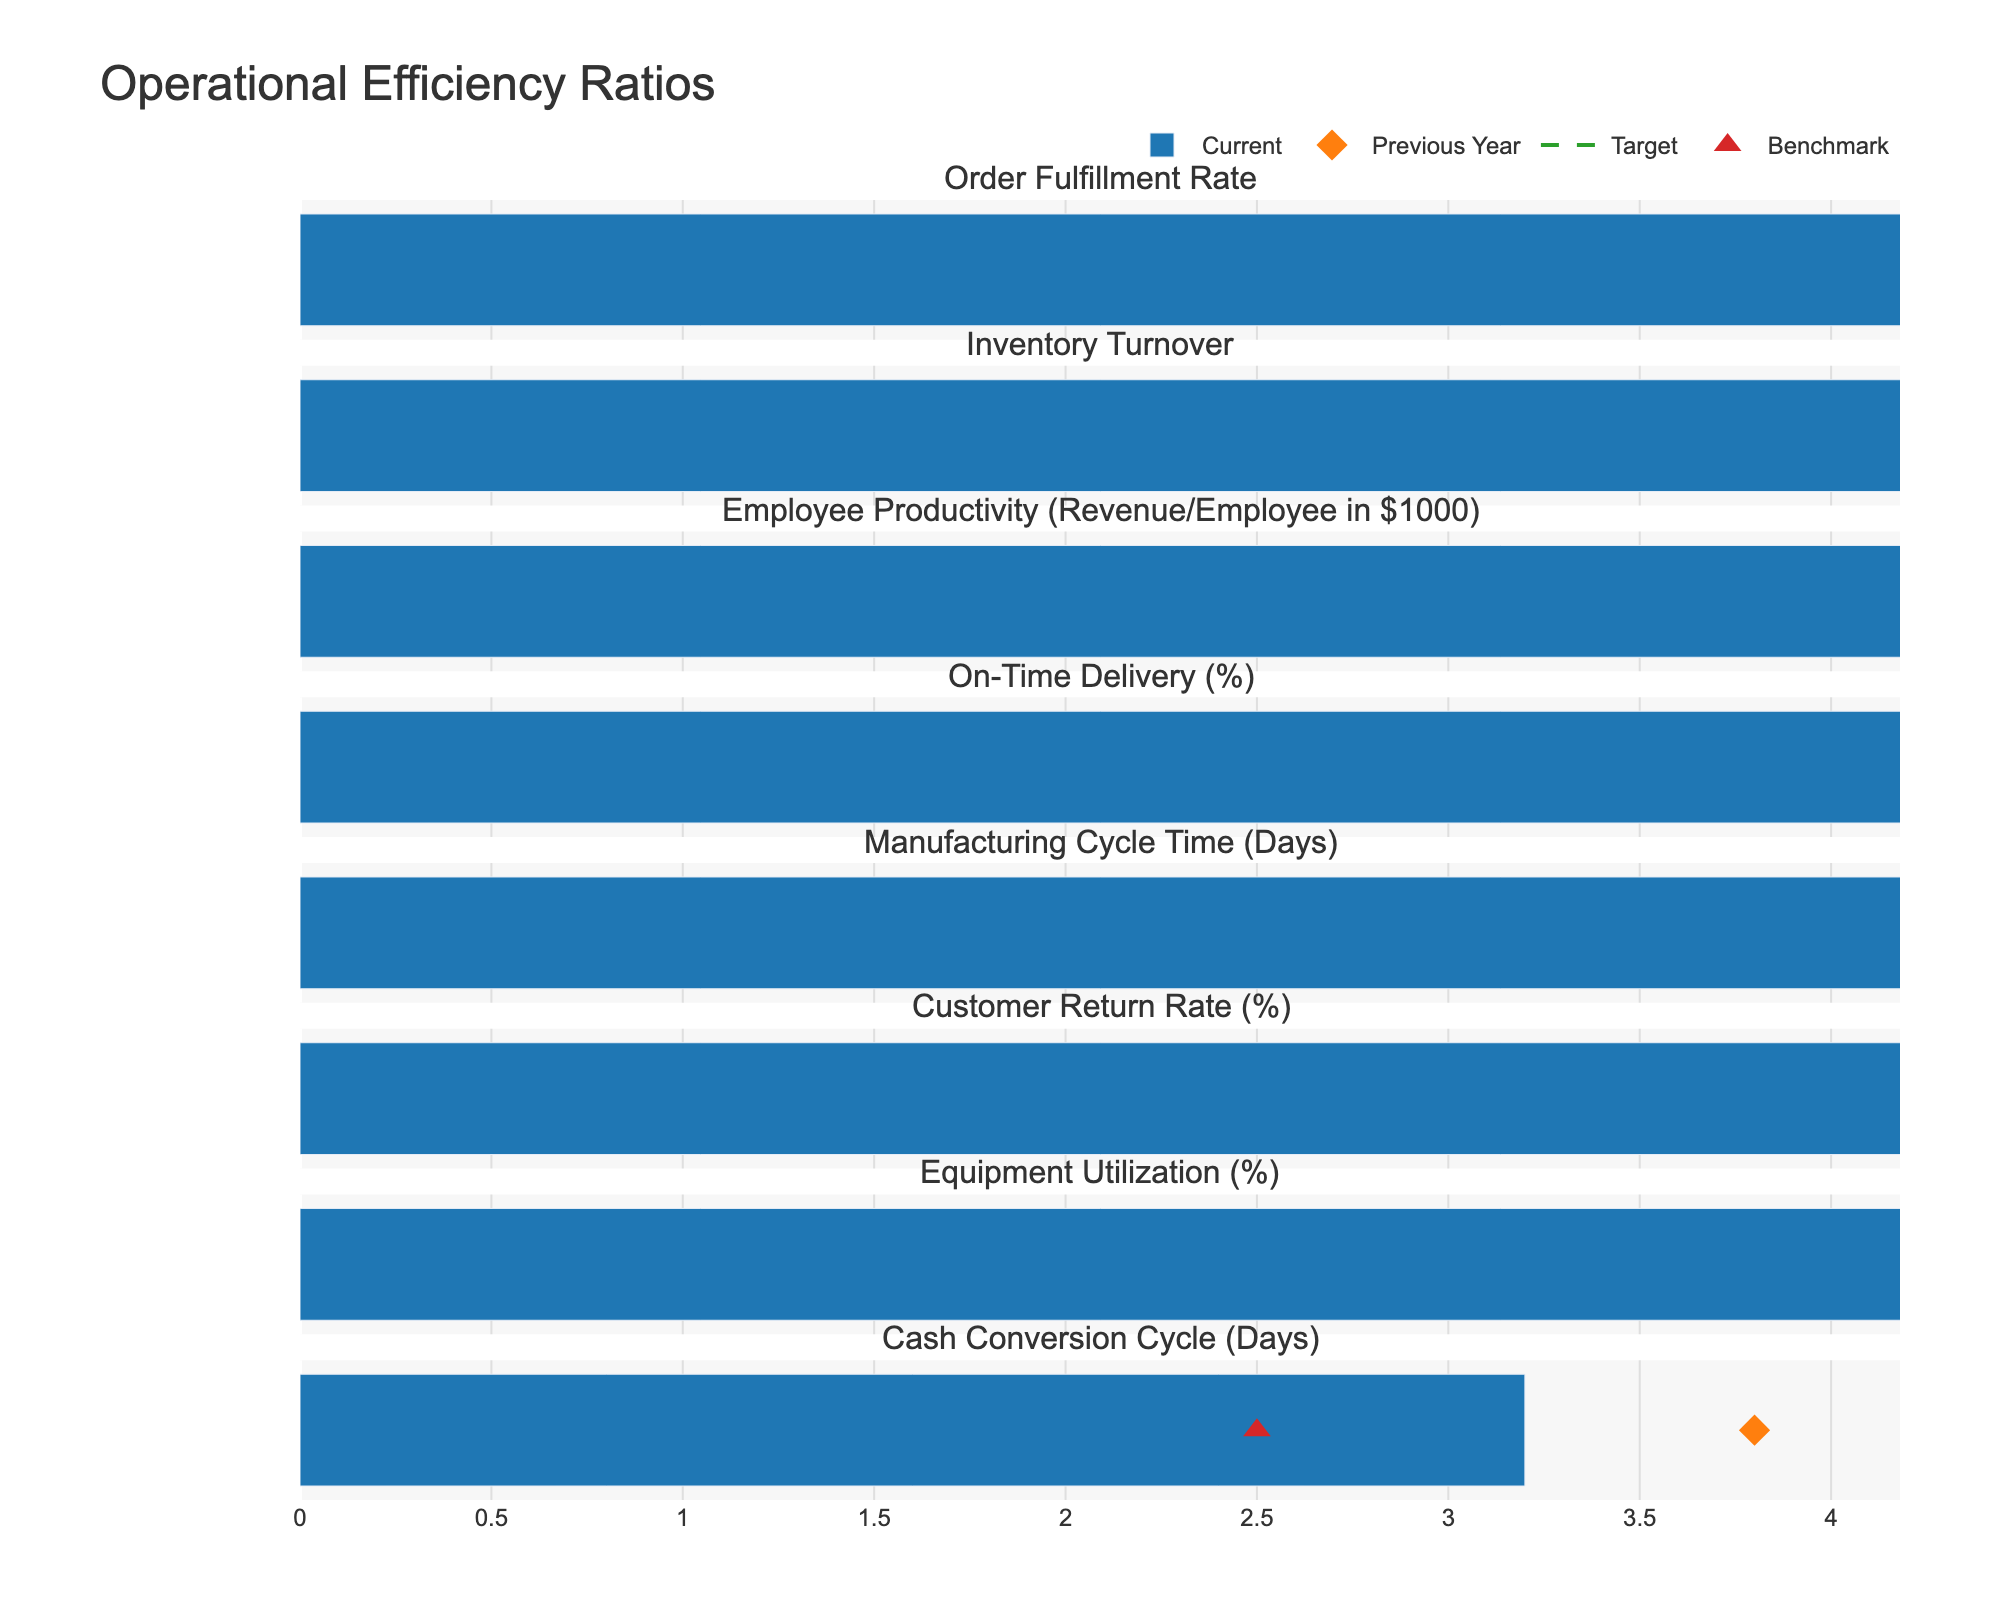what is the title of the figure? The title of the figure is located at the top center of the chart. It is usually the largest text and distinct from other elements, indicating a summary of the visual content.
Answer: Operational Efficiency Ratios Which metric had the highest current value? To find the metric with the highest current value, look at the bar lengths for current values and identify the one that extends the farthest to the right.
Answer: Order Fulfillment Rate What is the target value for Employee Productivity? Locate the Employee Productivity row and identify the dashed line which represents the target value.
Answer: 300 Which metrics have a current value that is below the target? Compare the lengths of the current value bars to the corresponding target values (dashed lines). Metrics where the bar is shorter than the dashed line are below target.
Answer: Employee Productivity, On-Time Delivery, Manufacturing Cycle Time, Equipment Utilization, Cash Conversion Cycle What is the difference in Inventory Turnover between the current year and the previous year? Subtract the previous year's value from the current year's value in the Inventory Turnover row. Current value is 6.8 and previous year is 6.2.
Answer: 0.6 Which metric has the greatest improvement from the previous year to the current year? Calculate the differences between current and previous year values for each metric, and identify the largest positive difference.
Answer: Cash Conversion Cycle How does the Customer Return Rate compare to its benchmark? Compare the current Customer Return Rate value (length of the current year’s bar) to the benchmark (triangle marker).
Answer: Higher than benchmark What is the range of values shown for the Manufacturing Cycle Time? To find the range, identify the maximum and minimum significant values displayed for Manufacturing Cycle Time. The maximum value can be the highest value seen (including targets and benchmarks if outside the typical range).
Answer: 9 to 14 Which metric is closest to hitting its target? Identify the metric where the current value is closest to the target value (dashed line).
Answer: Order Fulfillment Rate How much did the Equipment Utilization improve compared to the previous year? Look at the previous year’s value (diamond marker) and compare it to the current value (bar length) for Equipment Utilization. The previous year is 72, and the current year is 78.
Answer: 6 